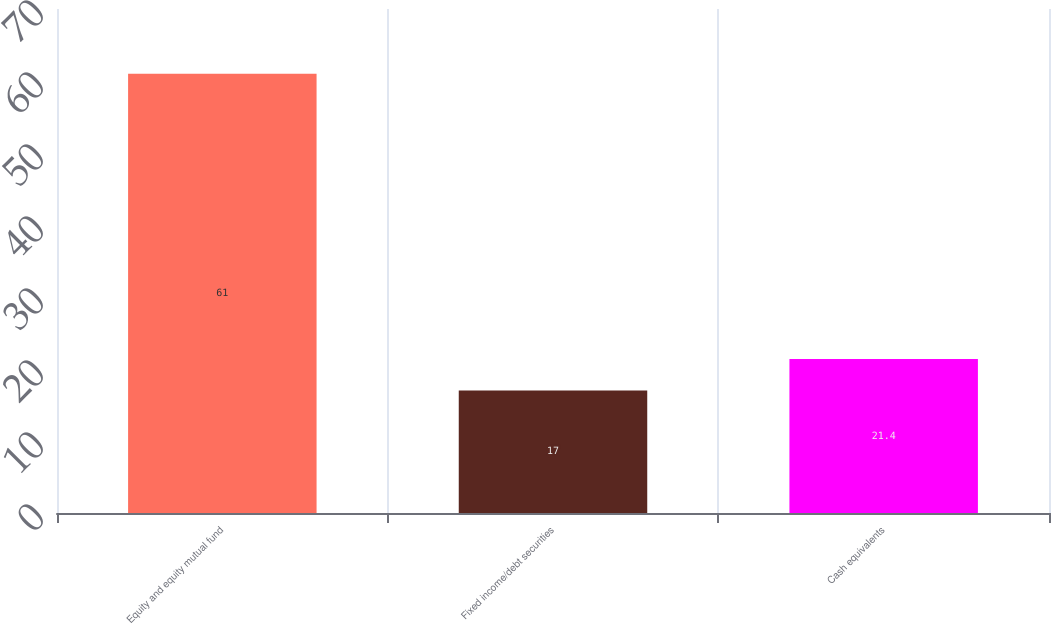Convert chart to OTSL. <chart><loc_0><loc_0><loc_500><loc_500><bar_chart><fcel>Equity and equity mutual fund<fcel>Fixed income/debt securities<fcel>Cash equivalents<nl><fcel>61<fcel>17<fcel>21.4<nl></chart> 